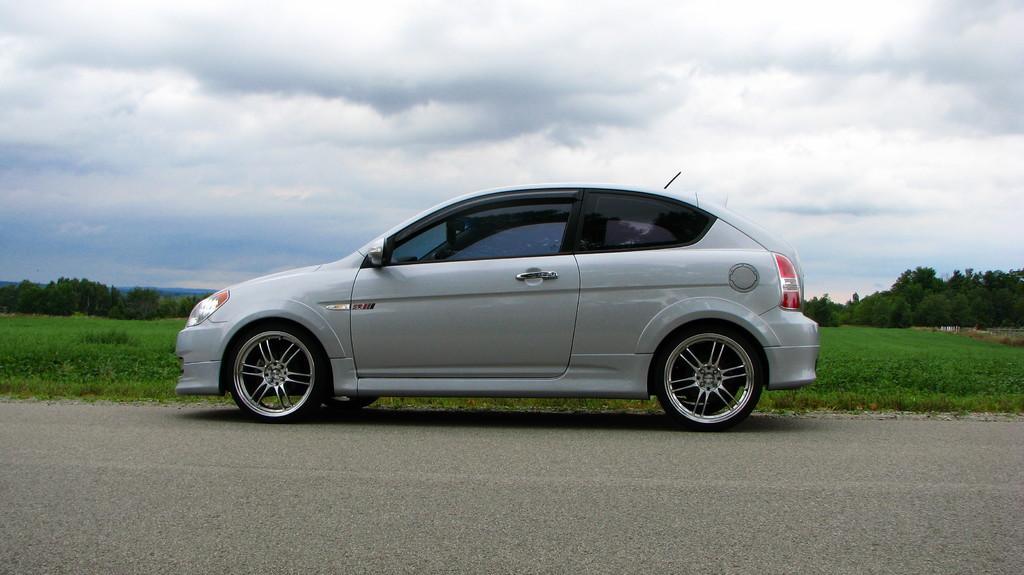Describe this image in one or two sentences. In this picture, there is a car on the road. The car is in grey in color. In the background, there is grass, trees and a sky with clouds. 